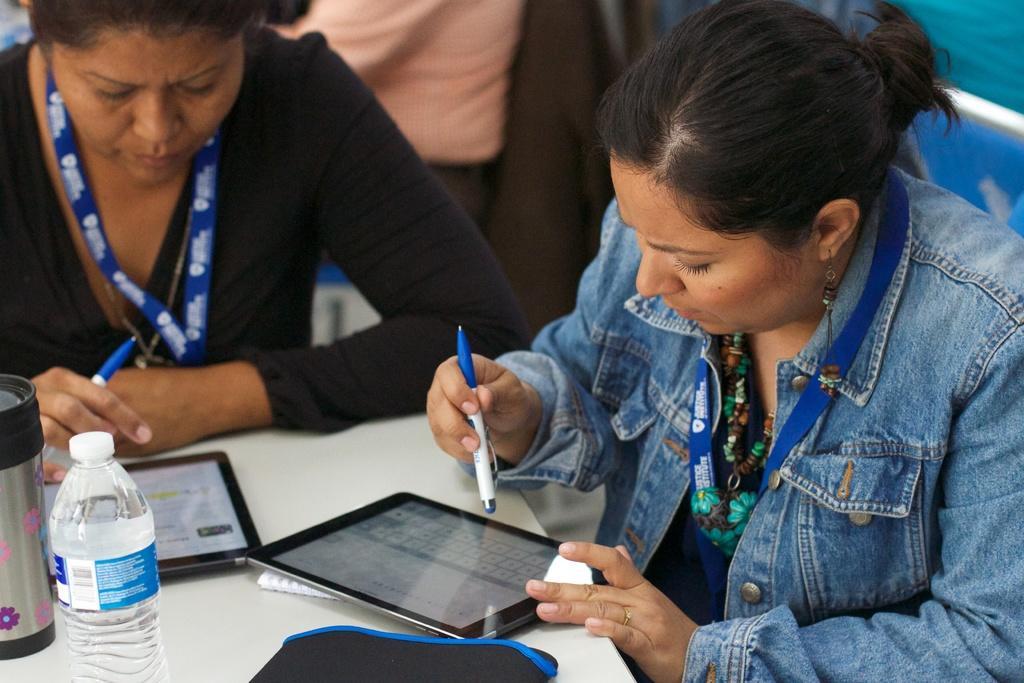In one or two sentences, can you explain what this image depicts? In this image I can see on the right side a woman is looking at the ipod, she wore jeans shirt and Id card. On the left side there is another woman also doing the same, she wore black color top. On the left side there is the water bottle on the table. 